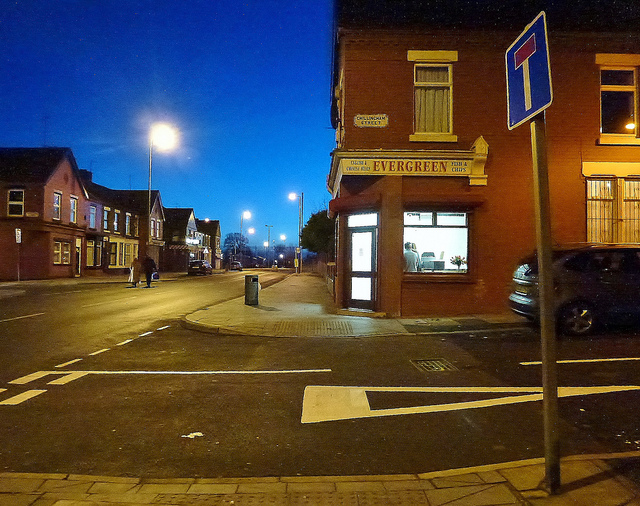Read all the text in this image. T EVERGREEN 